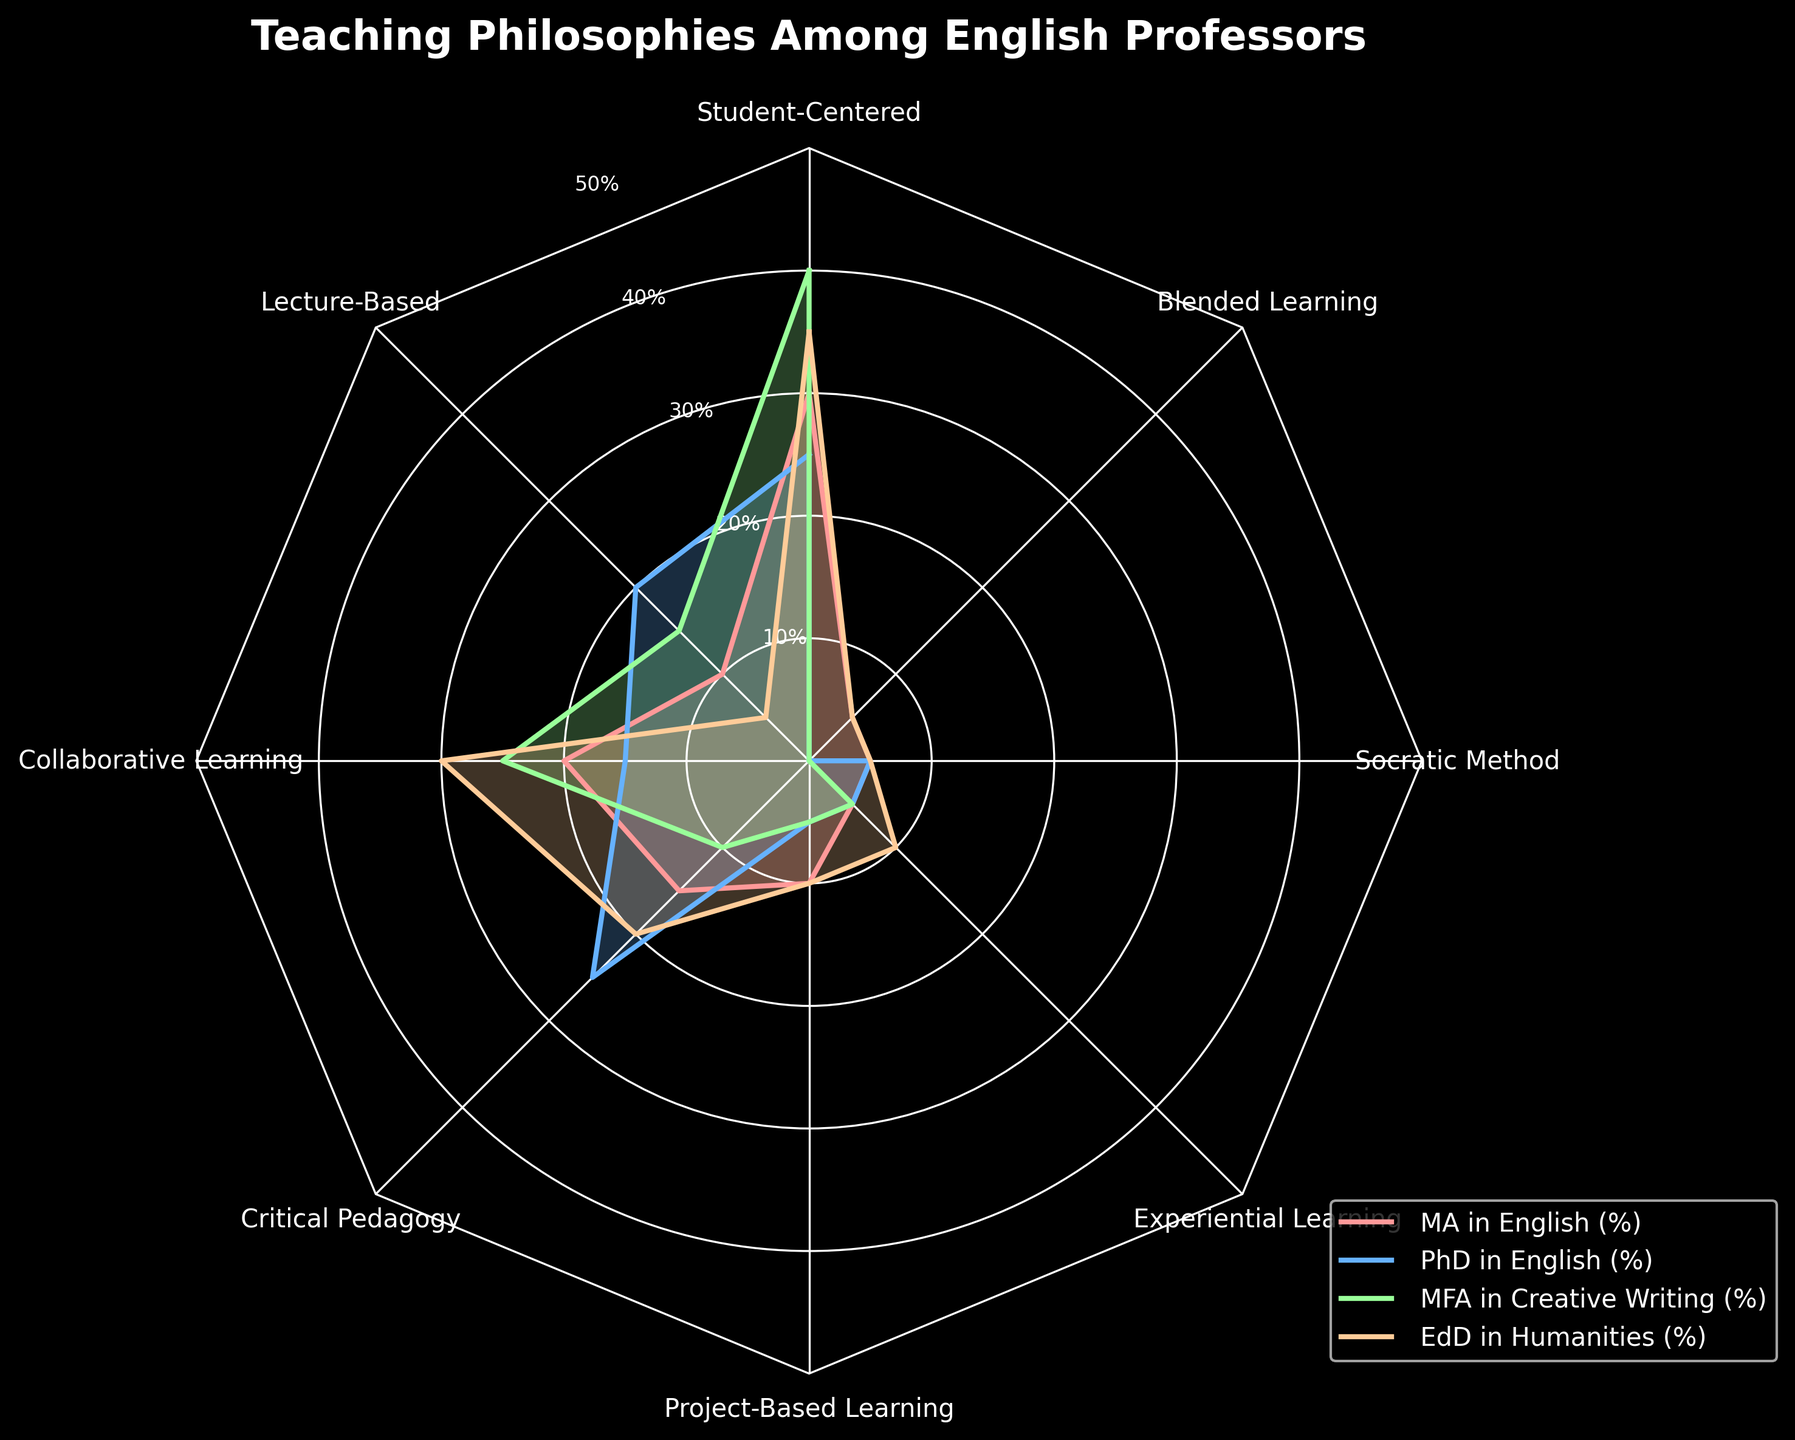What is the title of the figure? The title of the figure is usually found at the top center of the chart and clearly states its subject. Based on our code, it is placed with a white color and is bolded for emphasis.
Answer: Teaching Philosophies Among English Professors Which educational background focuses most on Collaborative Learning? On the radar chart, locate the axis labeled "Collaborative Learning," then look for the line extending furthest from the center on that axis.
Answer: EdD in Humanities What is the highest percentage for Socratic Method across all categories? Identify the radial axes corresponding to "Socratic Method" and check the values along these axes to see which line reaches the highest percentage.
Answer: MA in English, PhD in English, and EdD in Humanities (all 5%) How much higher is the percentage of Student-Centered teaching for MFA in Creative Writing than for PhD in English? Find the Student-Centered axis and identify the percentages for both MFA in Creative Writing and PhD in English. Subtract the smaller value from the larger value.
Answer: 15% Rank the educational backgrounds from highest to lowest based on their preference for Lecture-Based teaching. Locate the Lecture-Based axis and determine the percentage values for each educational background. Then rank these values from highest to lowest.
Answer: PhD in English, MFA in Creative Writing, MA in English, EdD in Humanities Which educational background has the least preference for Project-Based Learning and what is its percentage? On the Project-Based Learning axis, identify the smallest percentage among the educational backgrounds.
Answer: MFA in Creative Writing, 5% Does Student-Centered teaching have a higher percentage for MA in English or for EdD in Humanities? Compare the positions on the Student-Centered axis for both MA in English and EdD in Humanities and identify which one has the higher value.
Answer: EdD in Humanities Which teaching philosophy shows the least variation across all educational backgrounds? Observe the radar chart and look for the axis where the lines from different backgrounds are closest together, indicating minimal variation.
Answer: Socratic Method 